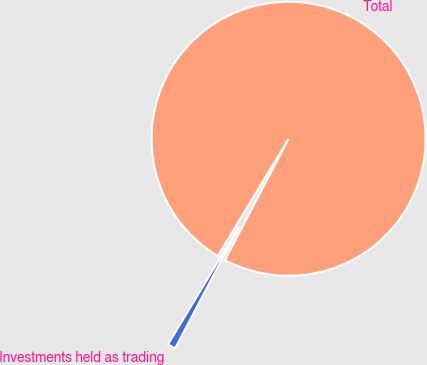Convert chart to OTSL. <chart><loc_0><loc_0><loc_500><loc_500><pie_chart><fcel>Investments held as trading<fcel>Total<nl><fcel>0.95%<fcel>99.05%<nl></chart> 